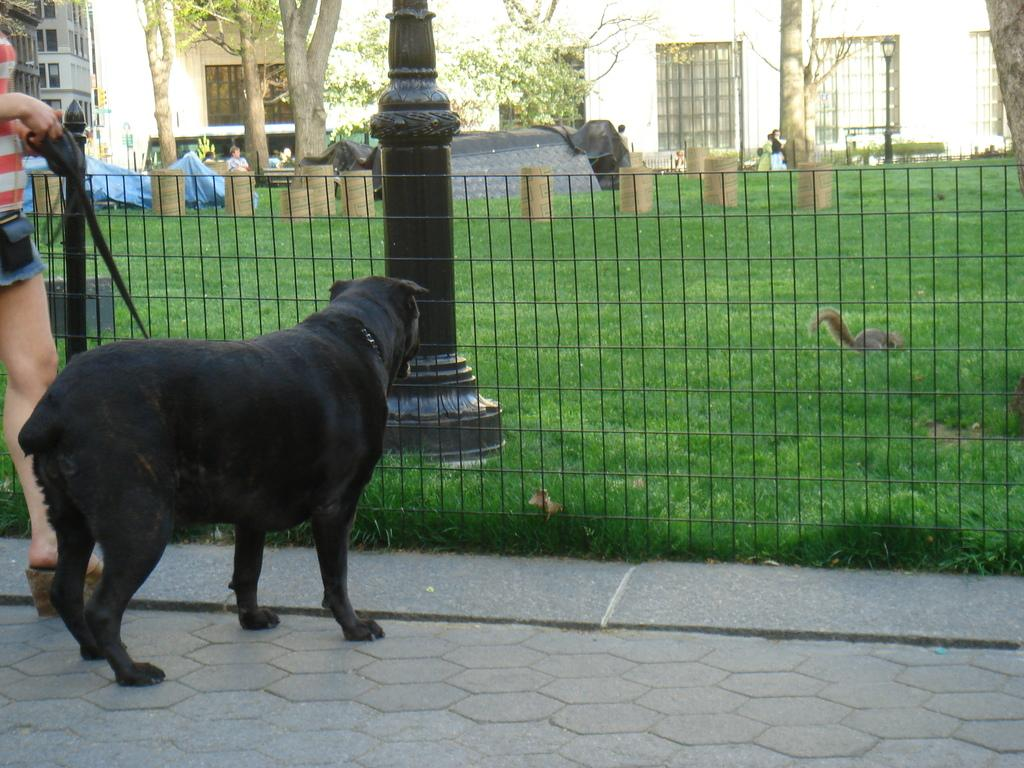Who or what is in the image? There is a person in the image. What is the person holding? The person is holding a black dog. Where is the person standing? The person is standing outside a fence. What can be seen on the other side of the fence? There is green grass, trees, and buildings visible on the other side of the fence. How many boats can be seen in the image? There are no boats visible in the image. Is the person swimming with the dog in the image? The person is not swimming with the dog in the image; they are standing outside a fence while holding the dog. 